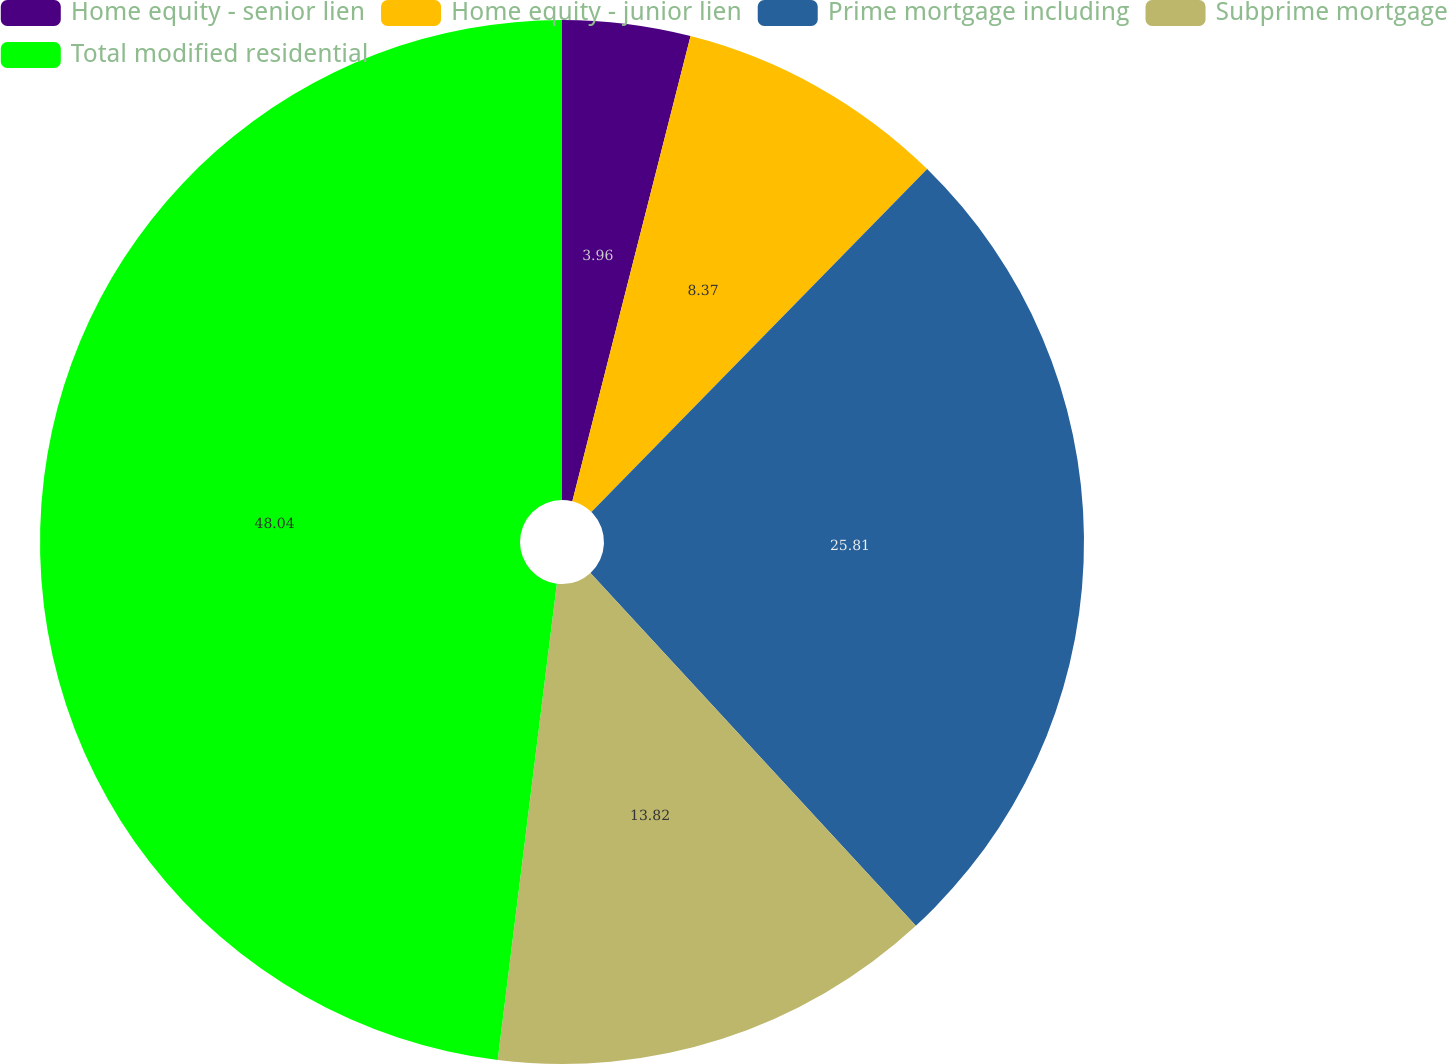<chart> <loc_0><loc_0><loc_500><loc_500><pie_chart><fcel>Home equity - senior lien<fcel>Home equity - junior lien<fcel>Prime mortgage including<fcel>Subprime mortgage<fcel>Total modified residential<nl><fcel>3.96%<fcel>8.37%<fcel>25.81%<fcel>13.82%<fcel>48.03%<nl></chart> 